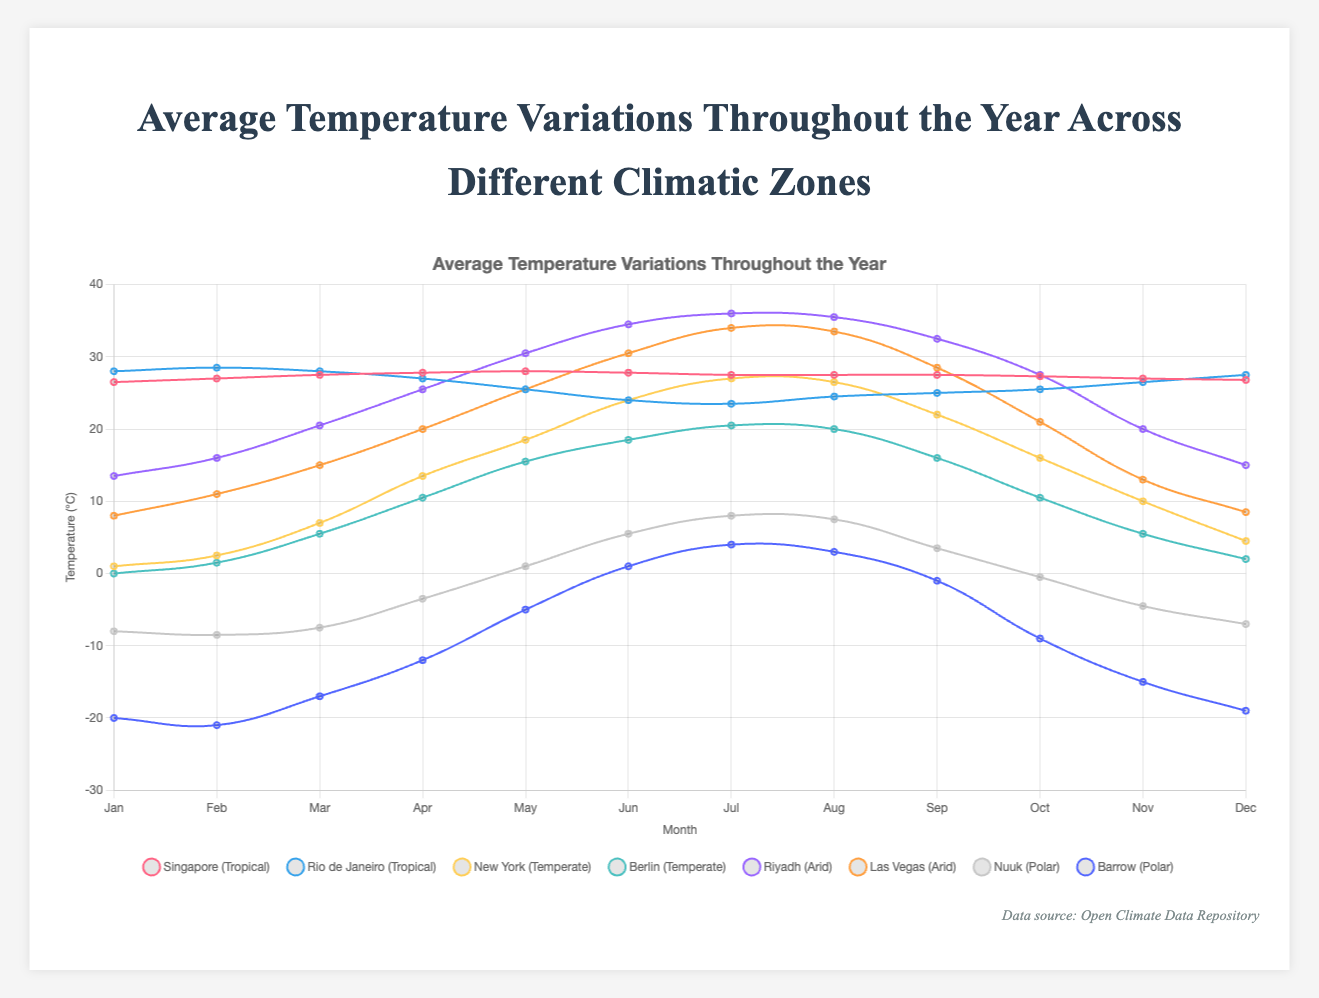What is the coldest month in Barrow? According to the figure, the lowest temperature recorded for Barrow is seen in January with an average temperature of -20°C.
Answer: January Which location in the Temperate zone has a higher average temperature in March? Comparing the March temperatures for New York (7.0°C) and Berlin (5.5°C), New York has a higher average temperature.
Answer: New York What is the average temperature for Riyadh in July and August? The temperatures recorded for Riyadh in July and August are 36.0°C and 35.5°C, respectively. The average can be calculated as (36.0 + 35.5) / 2 = 35.75°C.
Answer: 35.75°C Which city in the Arid zone shows a more significant temperature increase from January to July? For Riyadh, the temperature increase from January (13.5°C) to July (36.0°C) is 22.5°C. For Las Vegas, the increase from January (8.0°C) to July (34.0°C) is 26.0°C. Las Vegas shows a more significant increase.
Answer: Las Vegas In which month does New York have the highest average temperature? From the chart, the highest average temperature for New York is in July, with a temperature of 27.0°C.
Answer: July How does the temperature variation in Singapore compare with that in Rio de Janeiro in February? In February, Singapore has an average temperature of 27.0°C, while Rio de Janeiro has 28.5°C. Rio de Janeiro is warmer than Singapore by 1.5°C.
Answer: Rio de Janeiro is warmer by 1.5°C What is the temperature difference between Nuuk and Barrow in June? In June, the temperature for Nuuk is 5.5°C, while for Barrow, it is 1.0°C. The temperature difference is 5.5 - 1.0 = 4.5°C.
Answer: 4.5°C Which Polar location reaches above freezing temperatures earlier in the year, Nuuk or Barrow? By observing the temperature variations, Nuuk reaches an average temperature of 1.0°C in May, while Barrow reaches 1.0°C in June. Nuuk reaches above freezing temperatures earlier.
Answer: Nuuk Overall, which month has the most variation in temperatures across all locations? By inspecting the temperature variations across all locations, July shows the largest range of temperatures, from -17°C in Barrow to 36.0°C in Riyadh.
Answer: July 